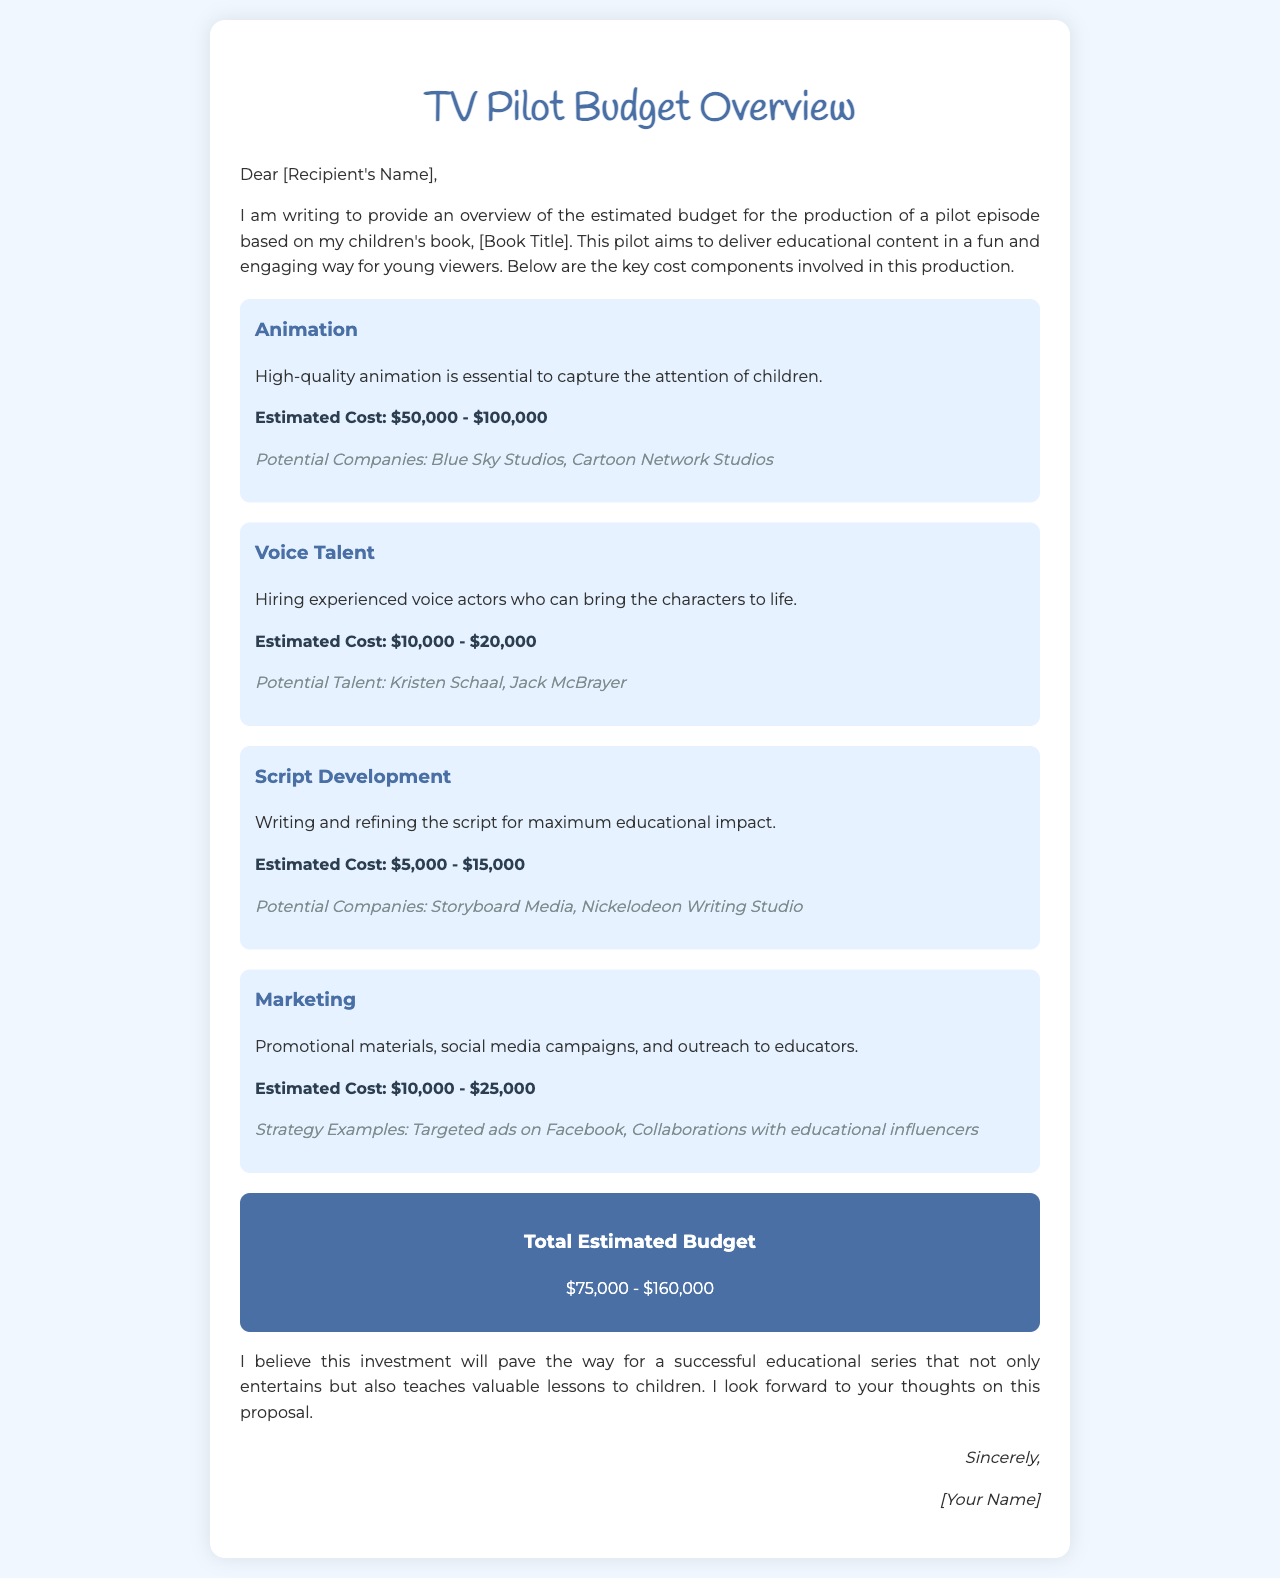What is the estimated cost range for Animation? The document lists the estimated cost for animation as $50,000 - $100,000.
Answer: $50,000 - $100,000 Who are the potential companies for Animation? The document mentions Blue Sky Studios and Cartoon Network Studios as potential companies for animation.
Answer: Blue Sky Studios, Cartoon Network Studios What is the estimated cost range for Voice Talent? The document specifies the estimated cost for voice talent as $10,000 - $20,000.
Answer: $10,000 - $20,000 What is the total estimated budget for the pilot? The total estimated budget is provided in the document as $75,000 - $160,000.
Answer: $75,000 - $160,000 What is the main goal of the pilot episode? The document states that the pilot aims to deliver educational content in a fun and engaging way.
Answer: Deliver educational content What is included in the Marketing cost? The document includes promotional materials, social media campaigns, and outreach to educators in the marketing cost.
Answer: Promotional materials, social media campaigns, and outreach to educators Which voice actor is mentioned as a potential voice talent? The document lists Kristen Schaal as a potential voice actor for the project.
Answer: Kristen Schaal What company is suggested for script development? The document mentions Storyboard Media as a potential company for script development.
Answer: Storyboard Media 